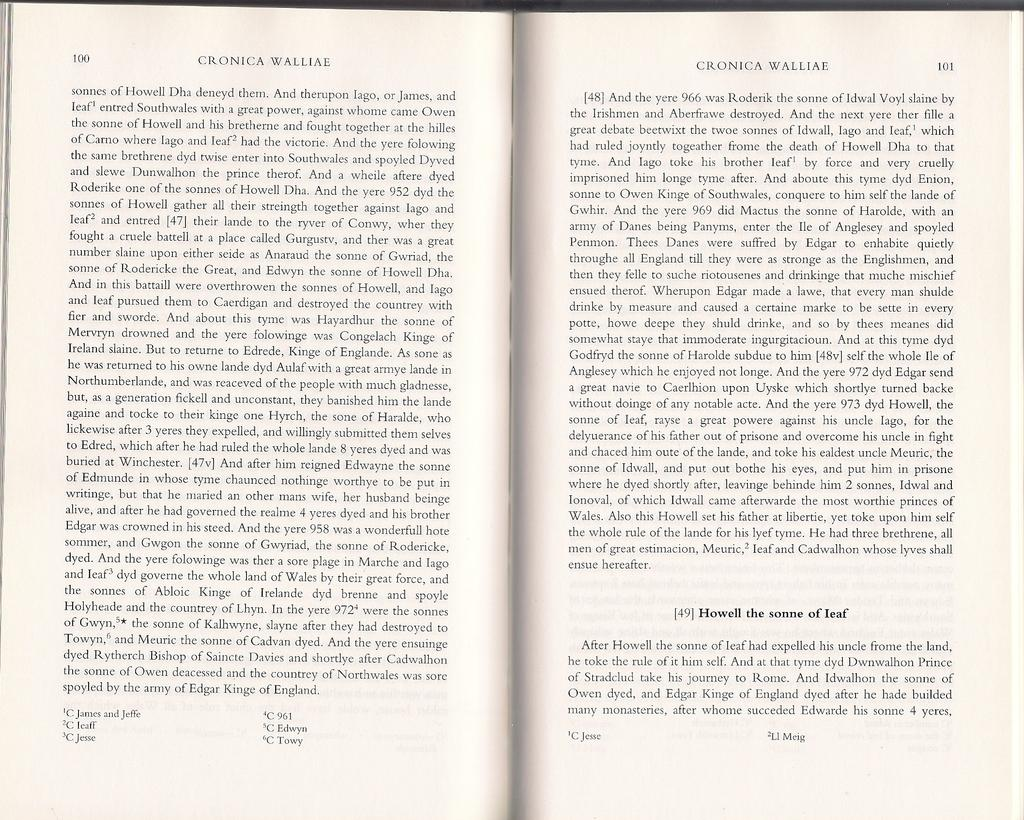<image>
Create a compact narrative representing the image presented. A book is open to page 100 which has the heading Cronica Walliae. 